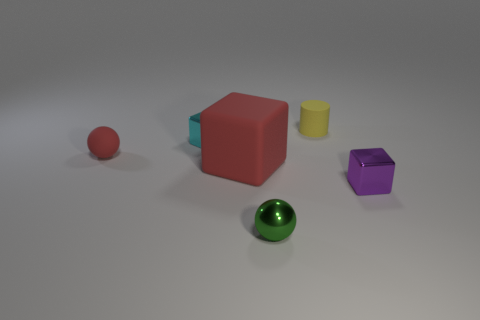Subtract all tiny blocks. How many blocks are left? 1 Add 2 red rubber cubes. How many objects exist? 8 Subtract all spheres. How many objects are left? 4 Subtract all tiny matte spheres. Subtract all purple metal cubes. How many objects are left? 4 Add 1 purple metallic blocks. How many purple metallic blocks are left? 2 Add 5 small purple matte cylinders. How many small purple matte cylinders exist? 5 Subtract 0 blue blocks. How many objects are left? 6 